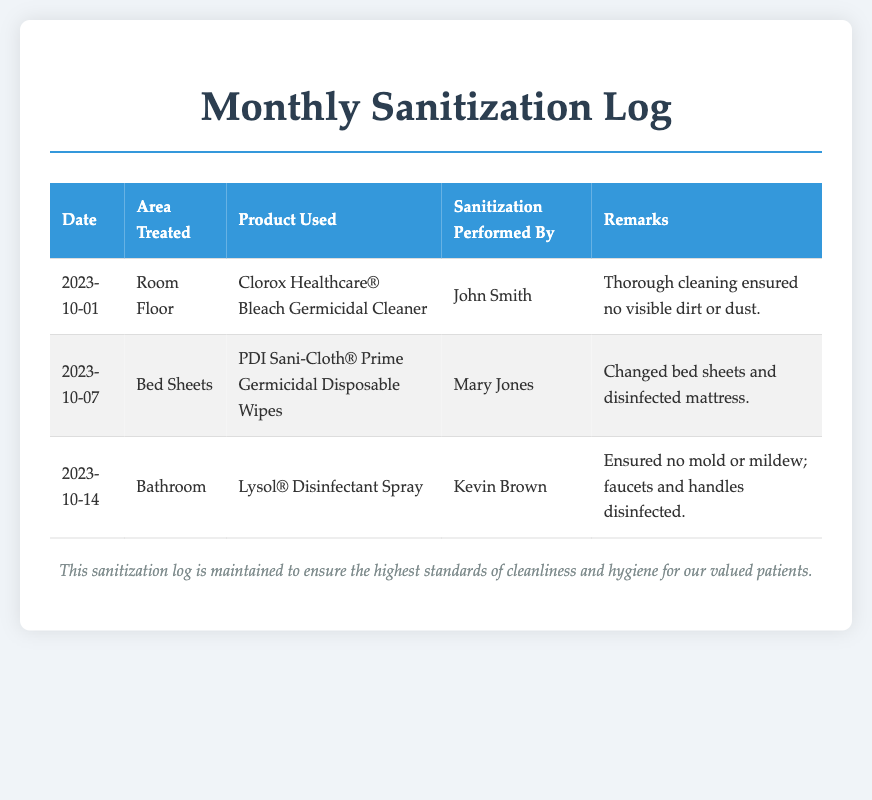What is the date when the room floor was treated? The log shows that the room floor was treated on October 1, 2023.
Answer: October 1, 2023 Who performed the sanitization of the bed sheets? According to the log, Mary Jones was responsible for sanitizing the bed sheets.
Answer: Mary Jones What product was used to disinfect the bathroom? The document states that Lysol® Disinfectant Spray was the product used for the bathroom.
Answer: Lysol® Disinfectant Spray How many areas were treated in October 2023? There were three areas treated as per the log: room floor, bed sheets, and bathroom.
Answer: 3 What remark was noted for the bathroom sanitization? The remark noted for the bathroom sanitization indicates that mold or mildew was not present and that faucets and handles were disinfected.
Answer: Ensured no mold or mildew; faucets and handles disinfected What is the overall purpose of the sanitization log? The log serves to maintain high standards of cleanliness and hygiene for the patients.
Answer: To ensure the highest standards of cleanliness and hygiene for our valued patients 